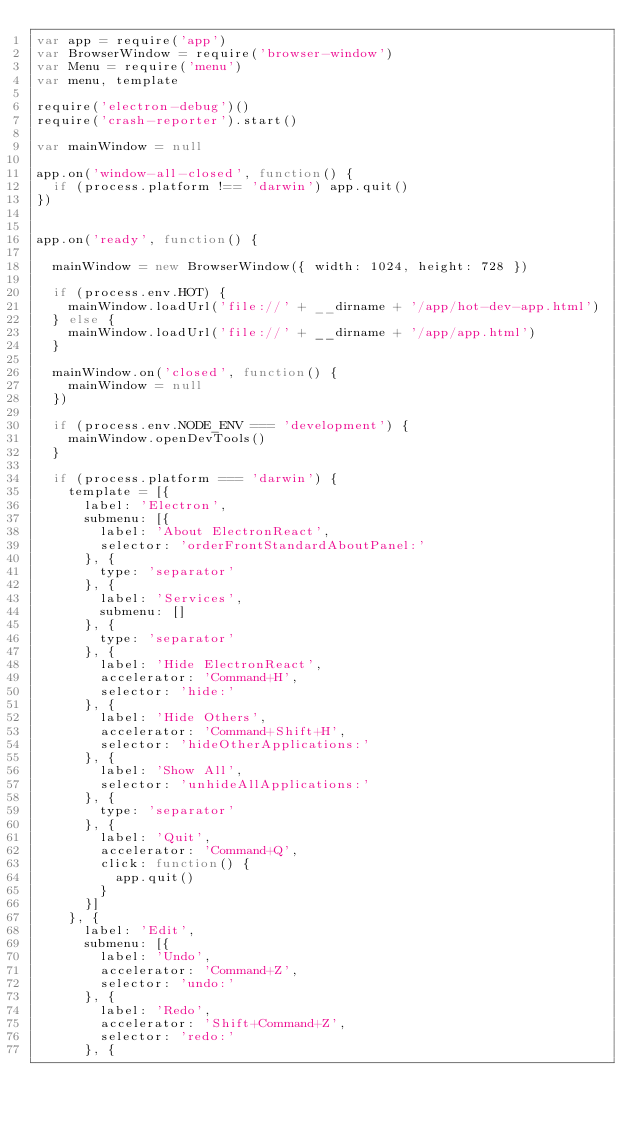<code> <loc_0><loc_0><loc_500><loc_500><_JavaScript_>var app = require('app')
var BrowserWindow = require('browser-window')
var Menu = require('menu')
var menu, template

require('electron-debug')()
require('crash-reporter').start()

var mainWindow = null

app.on('window-all-closed', function() {
  if (process.platform !== 'darwin') app.quit()
})


app.on('ready', function() {

  mainWindow = new BrowserWindow({ width: 1024, height: 728 })

  if (process.env.HOT) {
    mainWindow.loadUrl('file://' + __dirname + '/app/hot-dev-app.html')
  } else {
    mainWindow.loadUrl('file://' + __dirname + '/app/app.html')
  }

  mainWindow.on('closed', function() {
    mainWindow = null
  })

  if (process.env.NODE_ENV === 'development') {
    mainWindow.openDevTools()
  }

  if (process.platform === 'darwin') {
    template = [{
      label: 'Electron',
      submenu: [{
        label: 'About ElectronReact',
        selector: 'orderFrontStandardAboutPanel:'
      }, {
        type: 'separator'
      }, {
        label: 'Services',
        submenu: []
      }, {
        type: 'separator'
      }, {
        label: 'Hide ElectronReact',
        accelerator: 'Command+H',
        selector: 'hide:'
      }, {
        label: 'Hide Others',
        accelerator: 'Command+Shift+H',
        selector: 'hideOtherApplications:'
      }, {
        label: 'Show All',
        selector: 'unhideAllApplications:'
      }, {
        type: 'separator'
      }, {
        label: 'Quit',
        accelerator: 'Command+Q',
        click: function() {
          app.quit()
        }
      }]
    }, {
      label: 'Edit',
      submenu: [{
        label: 'Undo',
        accelerator: 'Command+Z',
        selector: 'undo:'
      }, {
        label: 'Redo',
        accelerator: 'Shift+Command+Z',
        selector: 'redo:'
      }, {</code> 